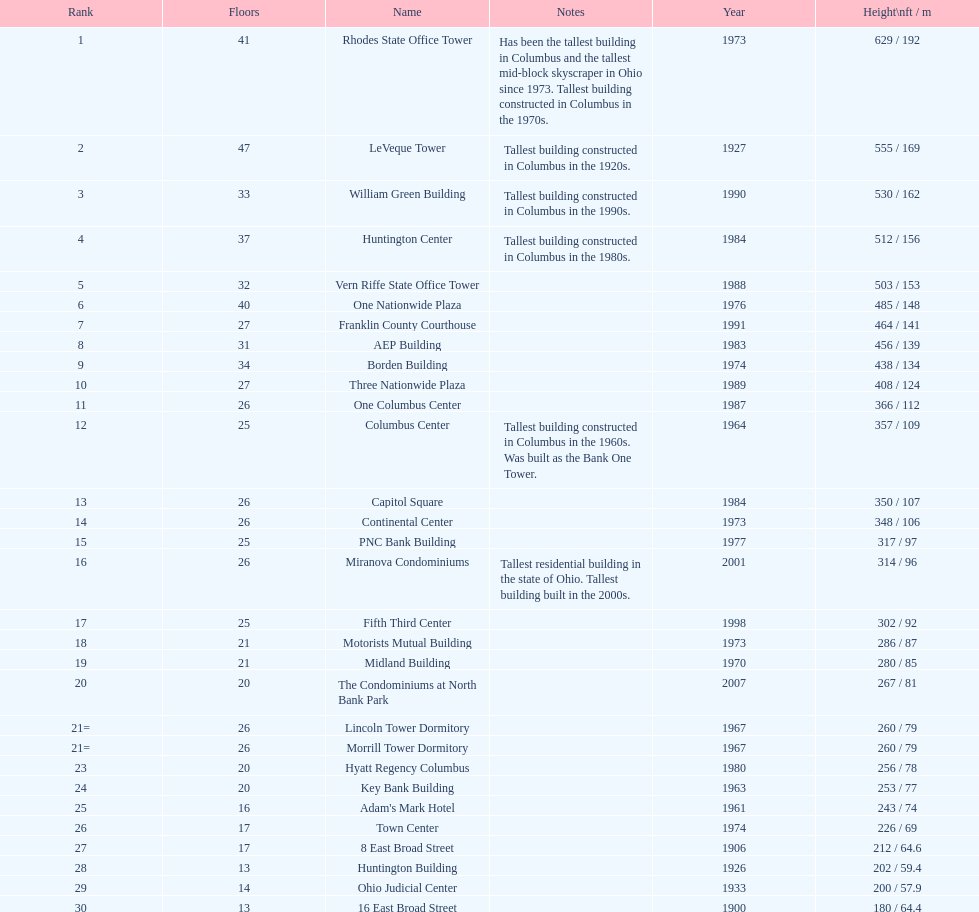Which buildings are taller than 500 ft? Rhodes State Office Tower, LeVeque Tower, William Green Building, Huntington Center, Vern Riffe State Office Tower. 